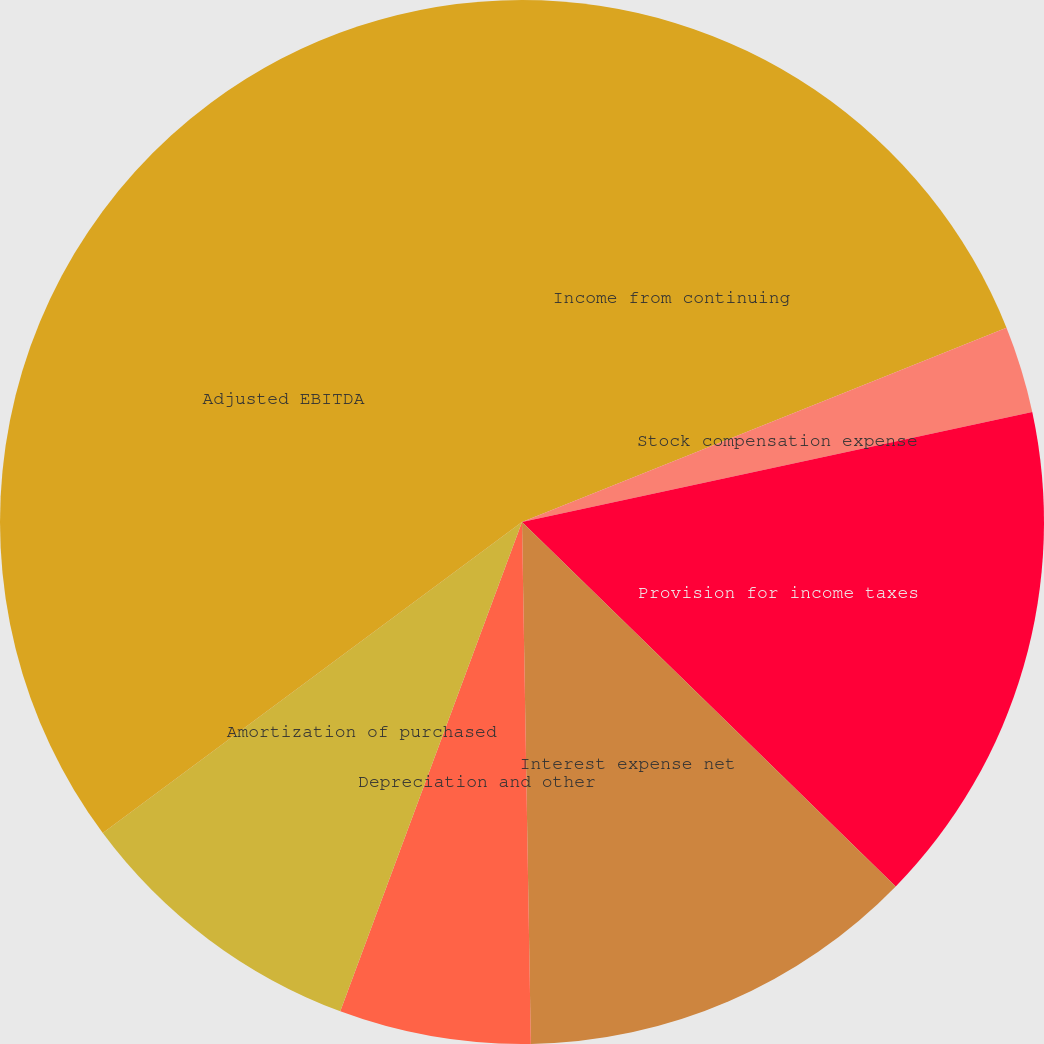Convert chart to OTSL. <chart><loc_0><loc_0><loc_500><loc_500><pie_chart><fcel>Income from continuing<fcel>Stock compensation expense<fcel>Provision for income taxes<fcel>Interest expense net<fcel>Depreciation and other<fcel>Amortization of purchased<fcel>Adjusted EBITDA<nl><fcel>18.93%<fcel>2.69%<fcel>15.68%<fcel>12.43%<fcel>5.93%<fcel>9.18%<fcel>35.16%<nl></chart> 